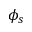<formula> <loc_0><loc_0><loc_500><loc_500>\phi _ { s }</formula> 